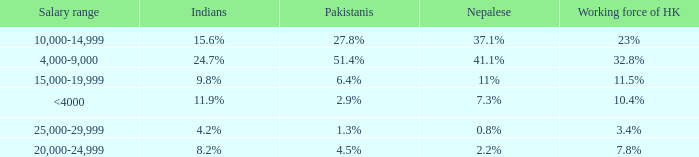If the salary range is 4,000-9,000, what is the Indians %? 24.7%. 